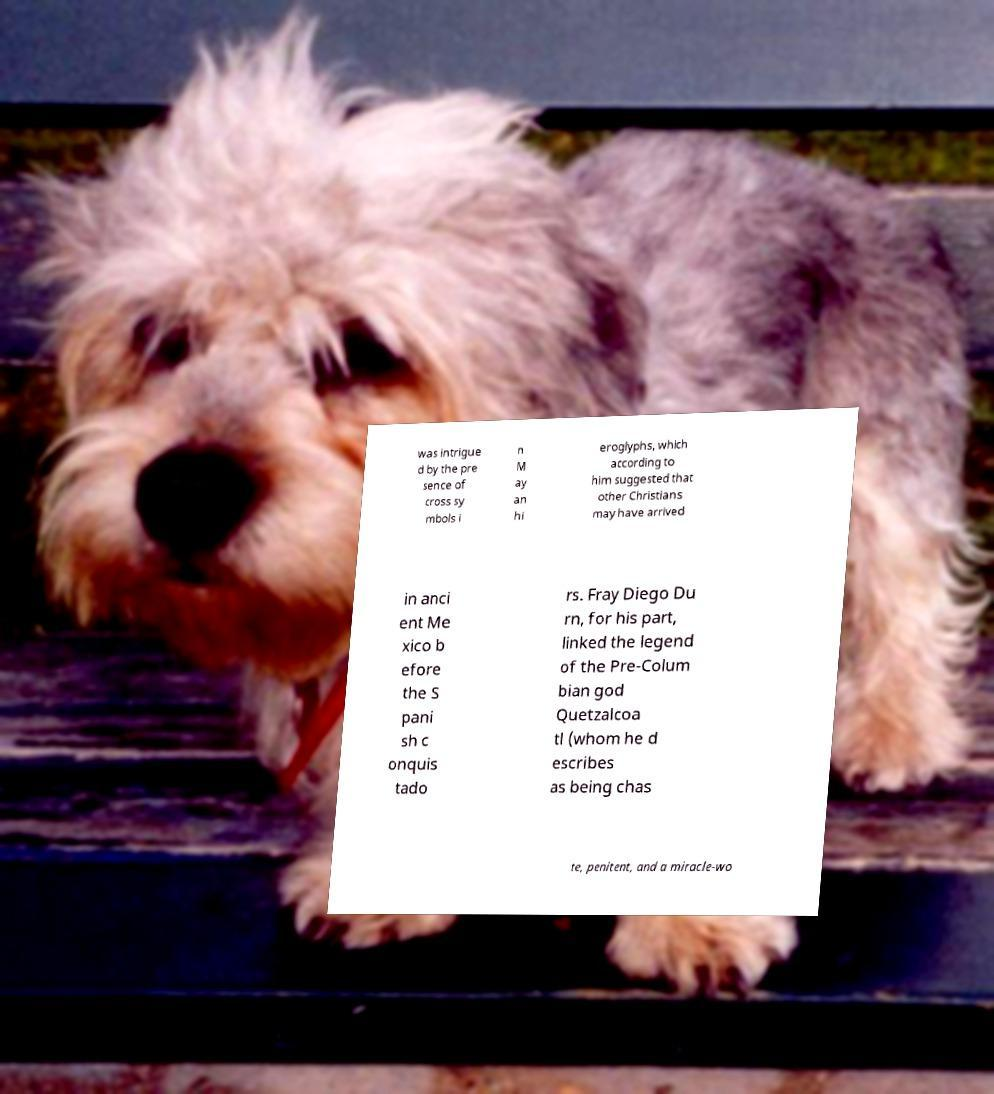I need the written content from this picture converted into text. Can you do that? was intrigue d by the pre sence of cross sy mbols i n M ay an hi eroglyphs, which according to him suggested that other Christians may have arrived in anci ent Me xico b efore the S pani sh c onquis tado rs. Fray Diego Du rn, for his part, linked the legend of the Pre-Colum bian god Quetzalcoa tl (whom he d escribes as being chas te, penitent, and a miracle-wo 